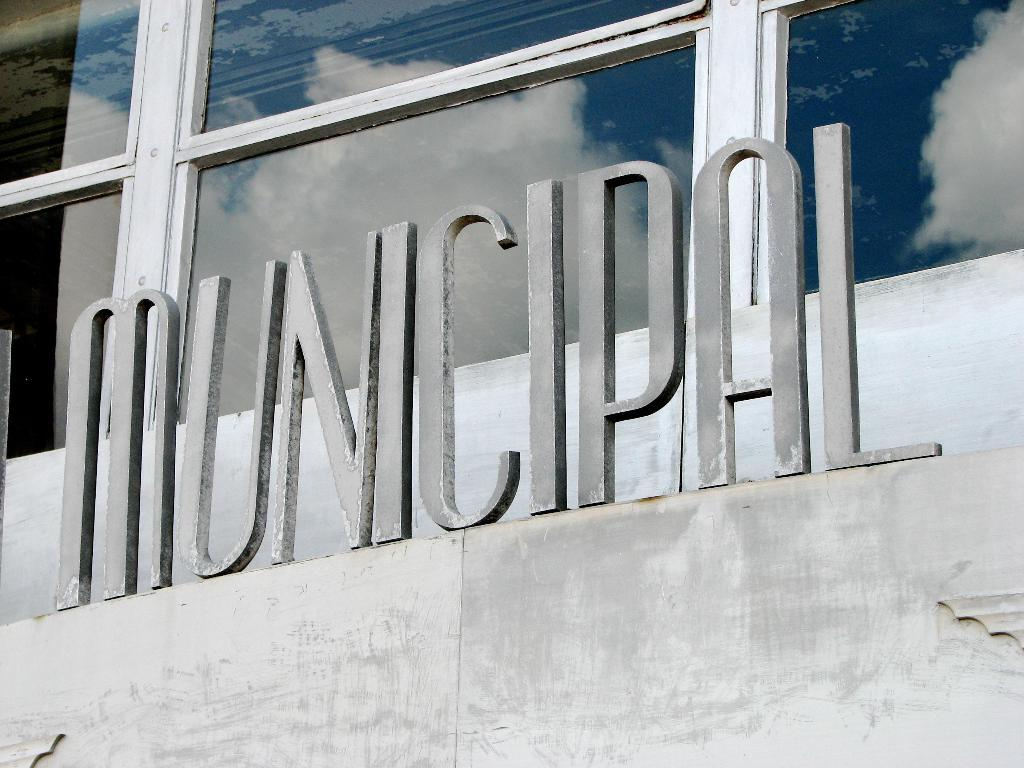What type of sign is visible in the image? There is a municipal sign in the image. Where is the municipal sign located? The municipal sign is placed on an object. What type of architectural feature can be seen in the image? There is a glass window in the image. What type of dinosaur is visible in the image? There are no dinosaurs present in the image. 